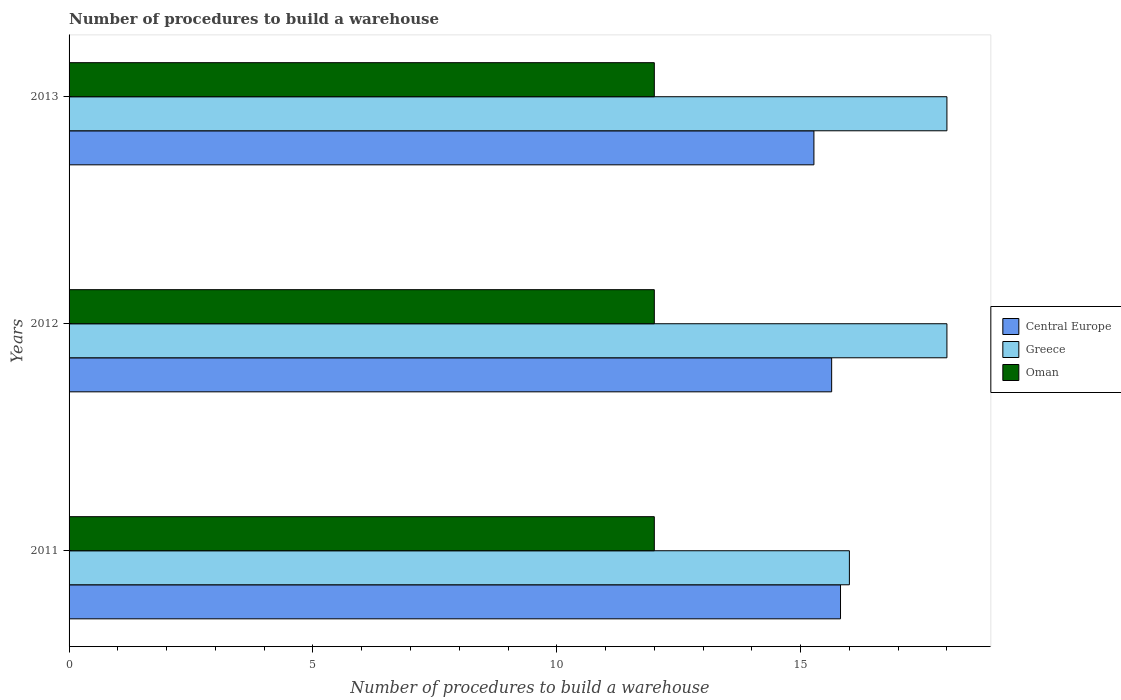How many different coloured bars are there?
Give a very brief answer. 3. Are the number of bars per tick equal to the number of legend labels?
Offer a very short reply. Yes. Are the number of bars on each tick of the Y-axis equal?
Provide a short and direct response. Yes. How many bars are there on the 1st tick from the bottom?
Offer a terse response. 3. What is the label of the 1st group of bars from the top?
Offer a terse response. 2013. What is the number of procedures to build a warehouse in in Central Europe in 2012?
Offer a very short reply. 15.64. Across all years, what is the maximum number of procedures to build a warehouse in in Central Europe?
Provide a short and direct response. 15.82. Across all years, what is the minimum number of procedures to build a warehouse in in Central Europe?
Make the answer very short. 15.27. In which year was the number of procedures to build a warehouse in in Oman maximum?
Make the answer very short. 2011. In which year was the number of procedures to build a warehouse in in Greece minimum?
Keep it short and to the point. 2011. What is the total number of procedures to build a warehouse in in Oman in the graph?
Give a very brief answer. 36. What is the difference between the number of procedures to build a warehouse in in Greece in 2011 and that in 2013?
Offer a terse response. -2. What is the difference between the number of procedures to build a warehouse in in Greece in 2011 and the number of procedures to build a warehouse in in Central Europe in 2013?
Your answer should be very brief. 0.73. What is the average number of procedures to build a warehouse in in Greece per year?
Provide a short and direct response. 17.33. In the year 2012, what is the difference between the number of procedures to build a warehouse in in Central Europe and number of procedures to build a warehouse in in Oman?
Give a very brief answer. 3.64. In how many years, is the number of procedures to build a warehouse in in Oman greater than 8 ?
Your response must be concise. 3. What is the difference between the highest and the lowest number of procedures to build a warehouse in in Greece?
Keep it short and to the point. 2. In how many years, is the number of procedures to build a warehouse in in Greece greater than the average number of procedures to build a warehouse in in Greece taken over all years?
Your response must be concise. 2. Is the sum of the number of procedures to build a warehouse in in Greece in 2011 and 2013 greater than the maximum number of procedures to build a warehouse in in Oman across all years?
Your answer should be compact. Yes. What does the 3rd bar from the top in 2013 represents?
Give a very brief answer. Central Europe. What does the 1st bar from the bottom in 2012 represents?
Your answer should be compact. Central Europe. Is it the case that in every year, the sum of the number of procedures to build a warehouse in in Oman and number of procedures to build a warehouse in in Greece is greater than the number of procedures to build a warehouse in in Central Europe?
Ensure brevity in your answer.  Yes. Are the values on the major ticks of X-axis written in scientific E-notation?
Offer a terse response. No. Does the graph contain any zero values?
Your answer should be compact. No. Does the graph contain grids?
Make the answer very short. No. Where does the legend appear in the graph?
Ensure brevity in your answer.  Center right. How are the legend labels stacked?
Keep it short and to the point. Vertical. What is the title of the graph?
Make the answer very short. Number of procedures to build a warehouse. Does "Timor-Leste" appear as one of the legend labels in the graph?
Provide a short and direct response. No. What is the label or title of the X-axis?
Ensure brevity in your answer.  Number of procedures to build a warehouse. What is the Number of procedures to build a warehouse in Central Europe in 2011?
Provide a short and direct response. 15.82. What is the Number of procedures to build a warehouse in Oman in 2011?
Keep it short and to the point. 12. What is the Number of procedures to build a warehouse of Central Europe in 2012?
Offer a very short reply. 15.64. What is the Number of procedures to build a warehouse in Oman in 2012?
Your answer should be very brief. 12. What is the Number of procedures to build a warehouse in Central Europe in 2013?
Make the answer very short. 15.27. What is the Number of procedures to build a warehouse in Greece in 2013?
Give a very brief answer. 18. Across all years, what is the maximum Number of procedures to build a warehouse in Central Europe?
Keep it short and to the point. 15.82. Across all years, what is the maximum Number of procedures to build a warehouse in Oman?
Offer a very short reply. 12. Across all years, what is the minimum Number of procedures to build a warehouse in Central Europe?
Ensure brevity in your answer.  15.27. Across all years, what is the minimum Number of procedures to build a warehouse in Greece?
Keep it short and to the point. 16. Across all years, what is the minimum Number of procedures to build a warehouse in Oman?
Ensure brevity in your answer.  12. What is the total Number of procedures to build a warehouse in Central Europe in the graph?
Keep it short and to the point. 46.73. What is the total Number of procedures to build a warehouse of Greece in the graph?
Your answer should be compact. 52. What is the total Number of procedures to build a warehouse in Oman in the graph?
Provide a short and direct response. 36. What is the difference between the Number of procedures to build a warehouse of Central Europe in 2011 and that in 2012?
Offer a very short reply. 0.18. What is the difference between the Number of procedures to build a warehouse of Central Europe in 2011 and that in 2013?
Give a very brief answer. 0.55. What is the difference between the Number of procedures to build a warehouse of Central Europe in 2012 and that in 2013?
Your answer should be compact. 0.36. What is the difference between the Number of procedures to build a warehouse in Oman in 2012 and that in 2013?
Ensure brevity in your answer.  0. What is the difference between the Number of procedures to build a warehouse in Central Europe in 2011 and the Number of procedures to build a warehouse in Greece in 2012?
Your answer should be compact. -2.18. What is the difference between the Number of procedures to build a warehouse in Central Europe in 2011 and the Number of procedures to build a warehouse in Oman in 2012?
Keep it short and to the point. 3.82. What is the difference between the Number of procedures to build a warehouse of Central Europe in 2011 and the Number of procedures to build a warehouse of Greece in 2013?
Provide a short and direct response. -2.18. What is the difference between the Number of procedures to build a warehouse in Central Europe in 2011 and the Number of procedures to build a warehouse in Oman in 2013?
Offer a terse response. 3.82. What is the difference between the Number of procedures to build a warehouse of Central Europe in 2012 and the Number of procedures to build a warehouse of Greece in 2013?
Your response must be concise. -2.36. What is the difference between the Number of procedures to build a warehouse in Central Europe in 2012 and the Number of procedures to build a warehouse in Oman in 2013?
Provide a succinct answer. 3.64. What is the difference between the Number of procedures to build a warehouse in Greece in 2012 and the Number of procedures to build a warehouse in Oman in 2013?
Provide a succinct answer. 6. What is the average Number of procedures to build a warehouse of Central Europe per year?
Give a very brief answer. 15.58. What is the average Number of procedures to build a warehouse in Greece per year?
Your answer should be compact. 17.33. What is the average Number of procedures to build a warehouse of Oman per year?
Offer a very short reply. 12. In the year 2011, what is the difference between the Number of procedures to build a warehouse in Central Europe and Number of procedures to build a warehouse in Greece?
Your response must be concise. -0.18. In the year 2011, what is the difference between the Number of procedures to build a warehouse of Central Europe and Number of procedures to build a warehouse of Oman?
Offer a very short reply. 3.82. In the year 2011, what is the difference between the Number of procedures to build a warehouse of Greece and Number of procedures to build a warehouse of Oman?
Keep it short and to the point. 4. In the year 2012, what is the difference between the Number of procedures to build a warehouse of Central Europe and Number of procedures to build a warehouse of Greece?
Ensure brevity in your answer.  -2.36. In the year 2012, what is the difference between the Number of procedures to build a warehouse of Central Europe and Number of procedures to build a warehouse of Oman?
Offer a very short reply. 3.64. In the year 2012, what is the difference between the Number of procedures to build a warehouse in Greece and Number of procedures to build a warehouse in Oman?
Ensure brevity in your answer.  6. In the year 2013, what is the difference between the Number of procedures to build a warehouse in Central Europe and Number of procedures to build a warehouse in Greece?
Ensure brevity in your answer.  -2.73. In the year 2013, what is the difference between the Number of procedures to build a warehouse in Central Europe and Number of procedures to build a warehouse in Oman?
Offer a terse response. 3.27. In the year 2013, what is the difference between the Number of procedures to build a warehouse of Greece and Number of procedures to build a warehouse of Oman?
Provide a succinct answer. 6. What is the ratio of the Number of procedures to build a warehouse in Central Europe in 2011 to that in 2012?
Offer a terse response. 1.01. What is the ratio of the Number of procedures to build a warehouse of Greece in 2011 to that in 2012?
Ensure brevity in your answer.  0.89. What is the ratio of the Number of procedures to build a warehouse of Oman in 2011 to that in 2012?
Offer a terse response. 1. What is the ratio of the Number of procedures to build a warehouse of Central Europe in 2011 to that in 2013?
Keep it short and to the point. 1.04. What is the ratio of the Number of procedures to build a warehouse of Greece in 2011 to that in 2013?
Your answer should be compact. 0.89. What is the ratio of the Number of procedures to build a warehouse of Oman in 2011 to that in 2013?
Offer a terse response. 1. What is the ratio of the Number of procedures to build a warehouse of Central Europe in 2012 to that in 2013?
Provide a succinct answer. 1.02. What is the ratio of the Number of procedures to build a warehouse of Oman in 2012 to that in 2013?
Offer a very short reply. 1. What is the difference between the highest and the second highest Number of procedures to build a warehouse of Central Europe?
Make the answer very short. 0.18. What is the difference between the highest and the second highest Number of procedures to build a warehouse of Greece?
Offer a very short reply. 0. What is the difference between the highest and the second highest Number of procedures to build a warehouse of Oman?
Provide a short and direct response. 0. What is the difference between the highest and the lowest Number of procedures to build a warehouse of Central Europe?
Make the answer very short. 0.55. What is the difference between the highest and the lowest Number of procedures to build a warehouse in Greece?
Your answer should be compact. 2. 